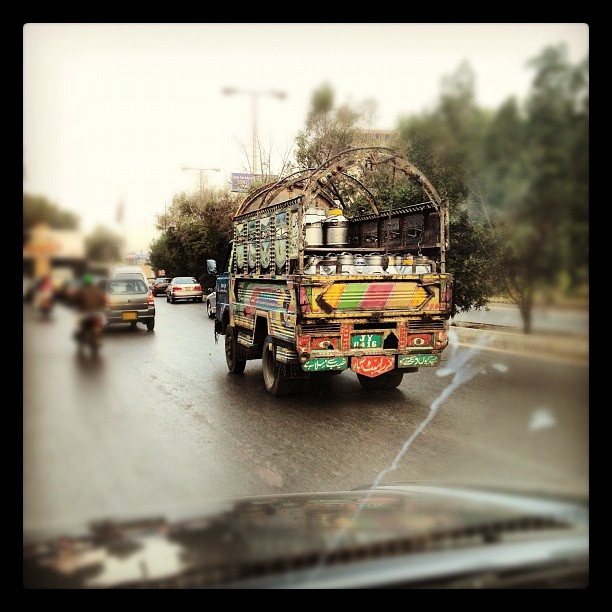Describe the objects in this image and their specific colors. I can see truck in black, tan, and gray tones, car in black, gray, darkgray, and maroon tones, people in black, maroon, gray, and darkgreen tones, car in black, beige, tan, and gray tones, and motorcycle in black, maroon, and gray tones in this image. 